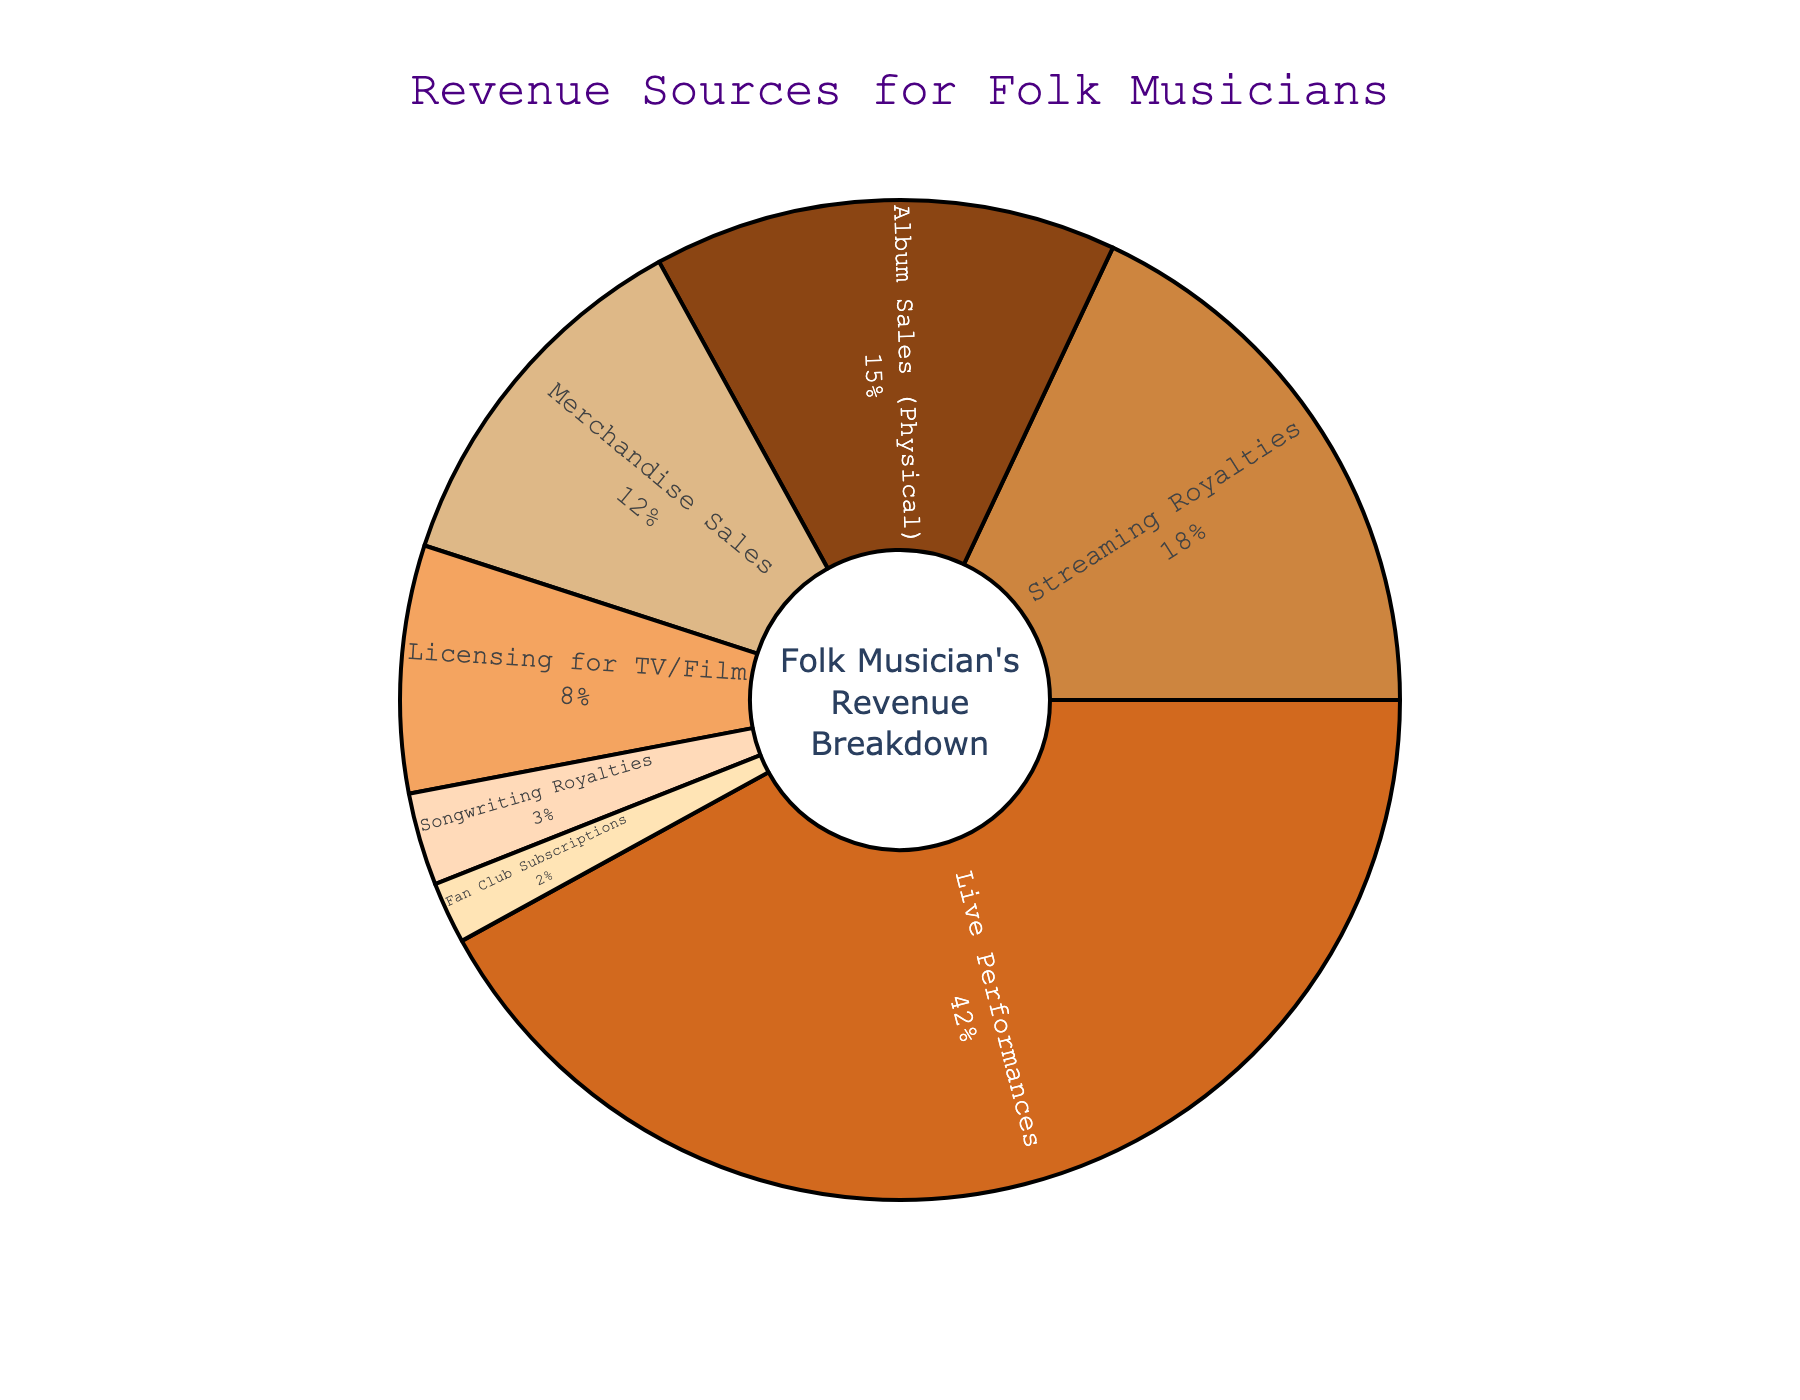What percentage of revenue comes from live performances? Live performances account for 42% of the revenue as indicated by the corresponding segment of the pie chart.
Answer: 42% Which revenue source contributes more, streaming royalties or merchandise sales? Streaming royalties contribute 18% to the revenue, while merchandise sales contribute 12%. Therefore, streaming royalties contribute more.
Answer: Streaming royalties What is the combined percentage of revenue from album sales (physical) and licensing for TV/Film? Album sales (physical) contribute 15%, and licensing for TV/Film contributes 8%. Combined, they add up to 15% + 8% = 23%.
Answer: 23% Is the percentage of revenue from songwriting royalties more or less than fan club subscriptions? Songwriting royalties account for 3% of the revenue, while fan club subscriptions account for 2%. Songwriting royalties are more.
Answer: More Which revenue source is the smallest, and what percentage does it represent? Fan club subscriptions are the smallest revenue source, representing 2% of the total revenue.
Answer: Fan club subscriptions, 2% Does live performances and merchandise sales together contribute more than 50% of the revenue? Live performances contribute 42% and merchandise sales contribute 12%, together they add up to 42% + 12% = 54%, which is more than 50%.
Answer: Yes Arrange the revenue sources in descending order of their contribution percentages. The percentages are: Live Performances (42%), Streaming Royalties (18%), Album Sales (Physical) (15%), Merchandise Sales (12%), Licensing for TV/Film (8%), Songwriting Royalties (3%), and Fan Club Subscriptions (2%).
Answer: Live Performances, Streaming Royalties, Album Sales (Physical), Merchandise Sales, Licensing for TV/Film, Songwriting Royalties, Fan Club Subscriptions How much more does licensing for TV/Film contribute compared to songwriting royalties? Licensing for TV/Film contributes 8%, whereas songwriting royalties contribute 3%. The difference is 8% - 3% = 5%.
Answer: 5% Is any single revenue source responsible for more than half of the total revenue? The largest revenue source is live performances, contributing 42%, which is less than half of the total revenue.
Answer: No 